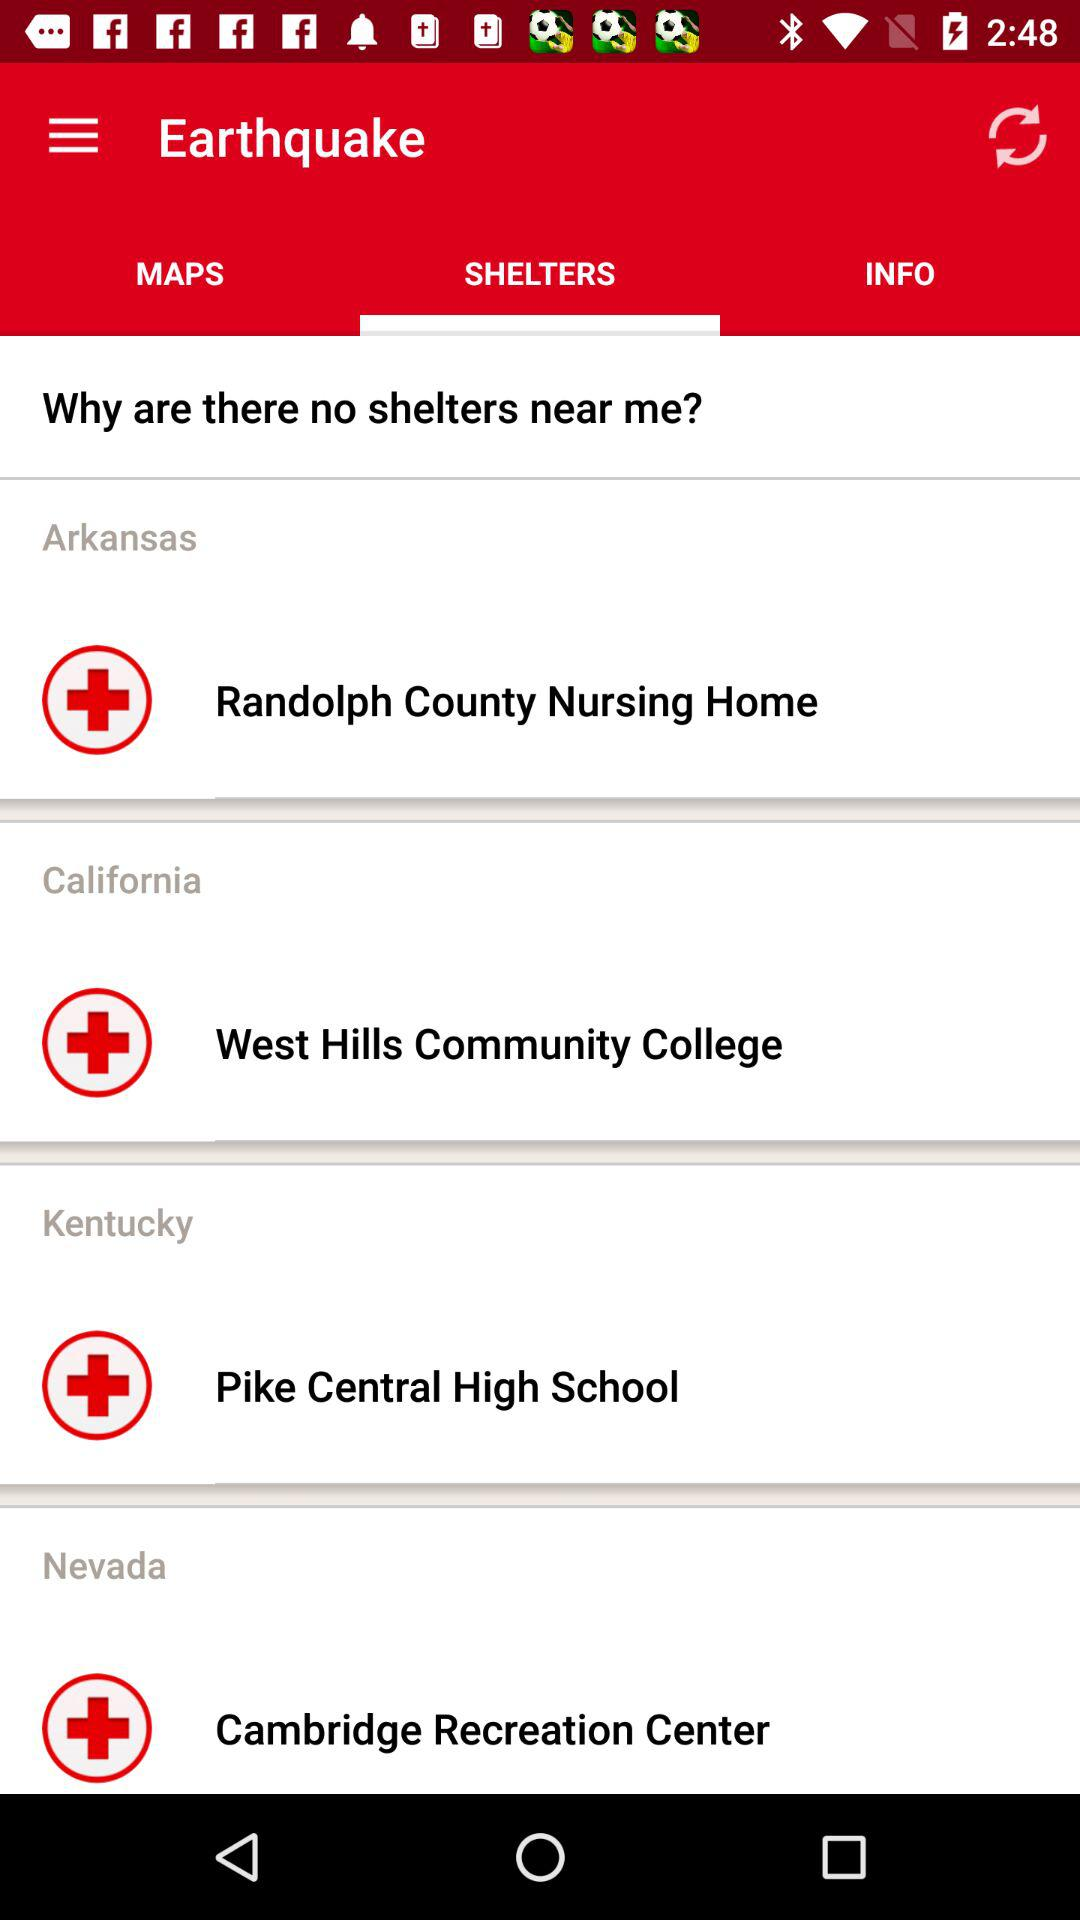Which tab has been selected? The selected tab is "SHELTERS". 